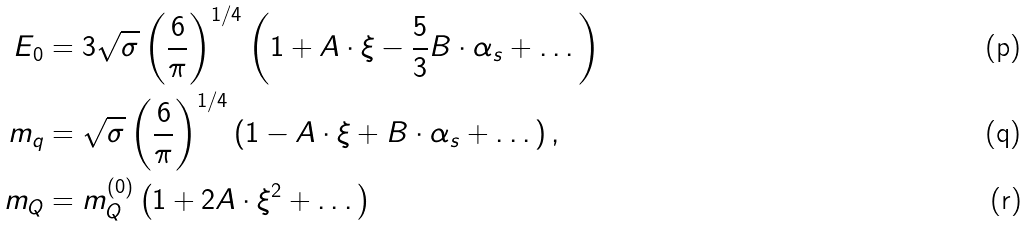Convert formula to latex. <formula><loc_0><loc_0><loc_500><loc_500>E _ { 0 } & = 3 \sqrt { \sigma } \left ( \frac { 6 } { \pi } \right ) ^ { 1 / 4 } \left ( 1 + A \cdot \xi - \frac { 5 } { 3 } B \cdot \alpha _ { s } + \dots \right ) \\ m _ { q } & = \sqrt { \sigma } \left ( \frac { 6 } { \pi } \right ) ^ { 1 / 4 } \left ( 1 - A \cdot \xi + B \cdot \alpha _ { s } + \dots \right ) , \\ m _ { Q } & = m _ { Q } ^ { ( 0 ) } \left ( 1 + 2 A \cdot \xi ^ { 2 } + \dots \right )</formula> 